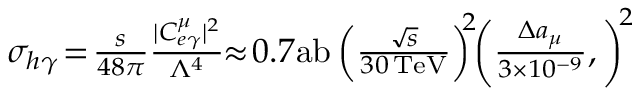<formula> <loc_0><loc_0><loc_500><loc_500>\begin{array} { r } { \sigma _ { h \gamma } \, = \, \frac { s } { 4 8 \pi } \frac { | C _ { e \gamma } ^ { \mu } | ^ { 2 } } { \Lambda ^ { 4 } } \, \approx \, 0 . 7 a b \left ( \frac { \sqrt { s } } { 3 0 \, T e V } \right ) ^ { \, 2 } \, \left ( \frac { \Delta a _ { \mu } } { 3 \times 1 0 ^ { - 9 } } , \right ) ^ { \, 2 } } \end{array}</formula> 